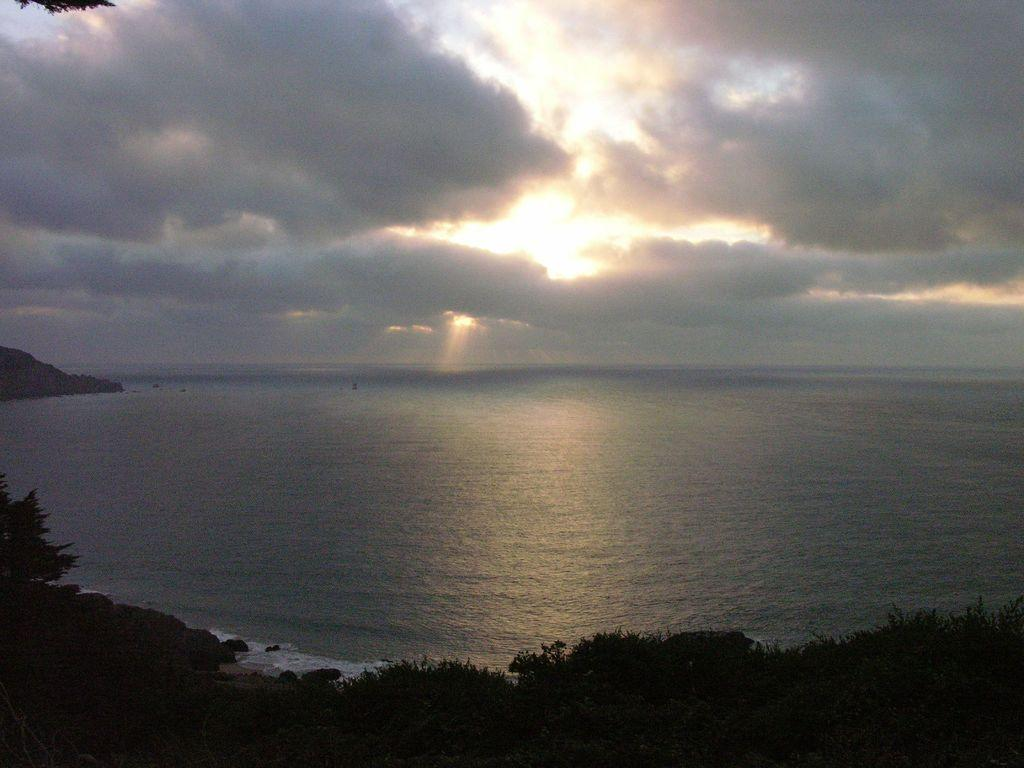What type of vegetation is at the bottom of the image? There are trees at the bottom of the image. What body of water is visible in the image? There is an ocean in the front of the image. What can be seen in the sky at the top of the image? There are clouds in the sky at the top of the image. What type of punishment is being discussed in the image? There is no discussion or punishment present in the image; it features trees, an ocean, and clouds. How many stars can be seen in the image? There are no stars visible in the image; it features trees, an ocean, and clouds. 